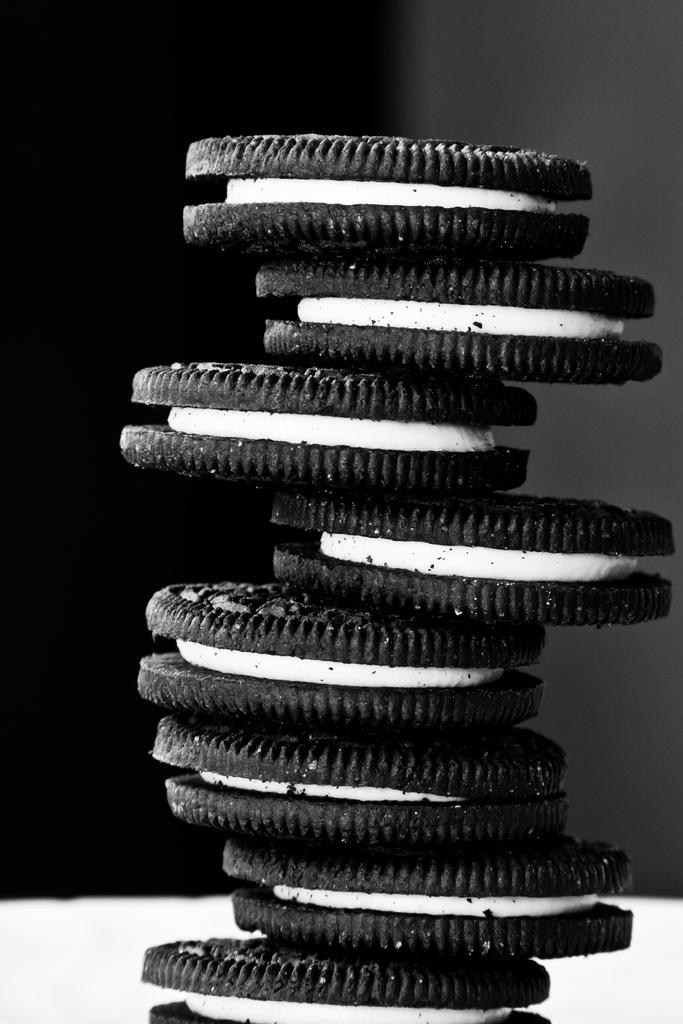What type of food can be seen in the image? There are biscuits in the image. What is the biscuits placed on in the image? There is a plate at the bottom of the image. How would you describe the color scheme of the background in the image? The background of the image is black and grey in color. How many watches are visible on the plate in the image? There are no watches present in the image; it features biscuits on a plate. What type of flower is shown next to the biscuits in the image? There is no flower, specifically a rose, present in the image; it only features biscuits on a plate. 